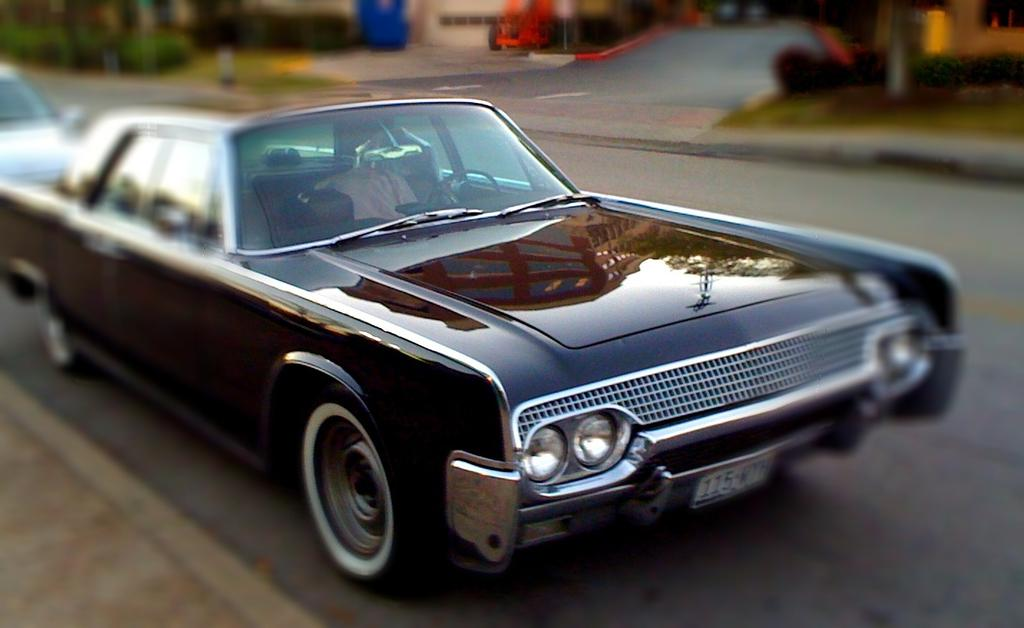What is present on the road in the image? There are vehicles on the road in the image. Can you describe the background of the image? The background of the image appears blurry. What flavor of wood can be seen in the pocket of the person in the image? There is no person or wood present in the image, so it is not possible to determine the flavor or any other characteristic of the wood. 